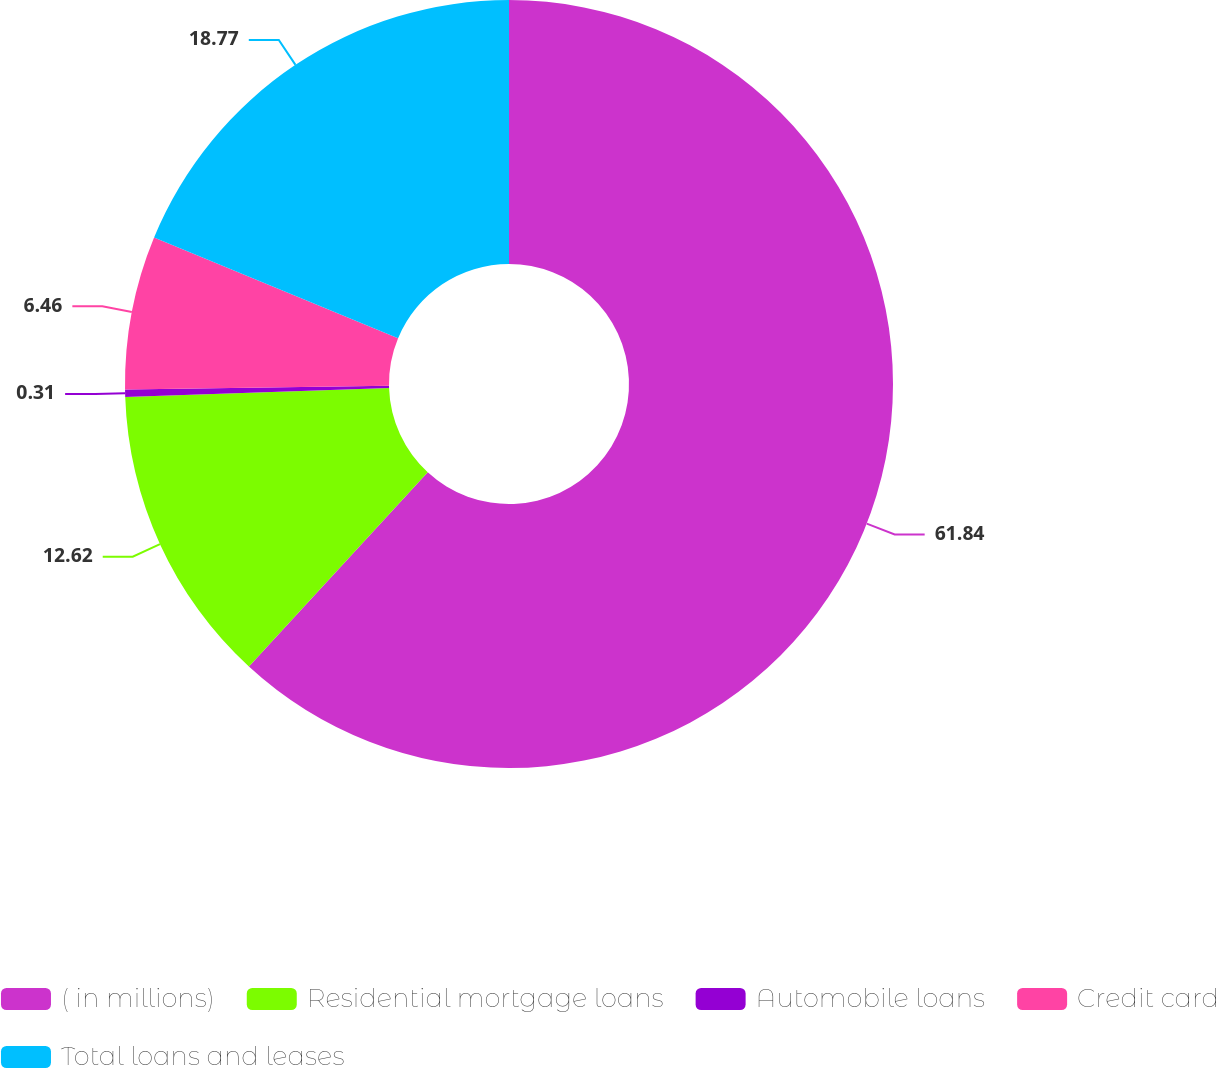<chart> <loc_0><loc_0><loc_500><loc_500><pie_chart><fcel>( in millions)<fcel>Residential mortgage loans<fcel>Automobile loans<fcel>Credit card<fcel>Total loans and leases<nl><fcel>61.85%<fcel>12.62%<fcel>0.31%<fcel>6.46%<fcel>18.77%<nl></chart> 